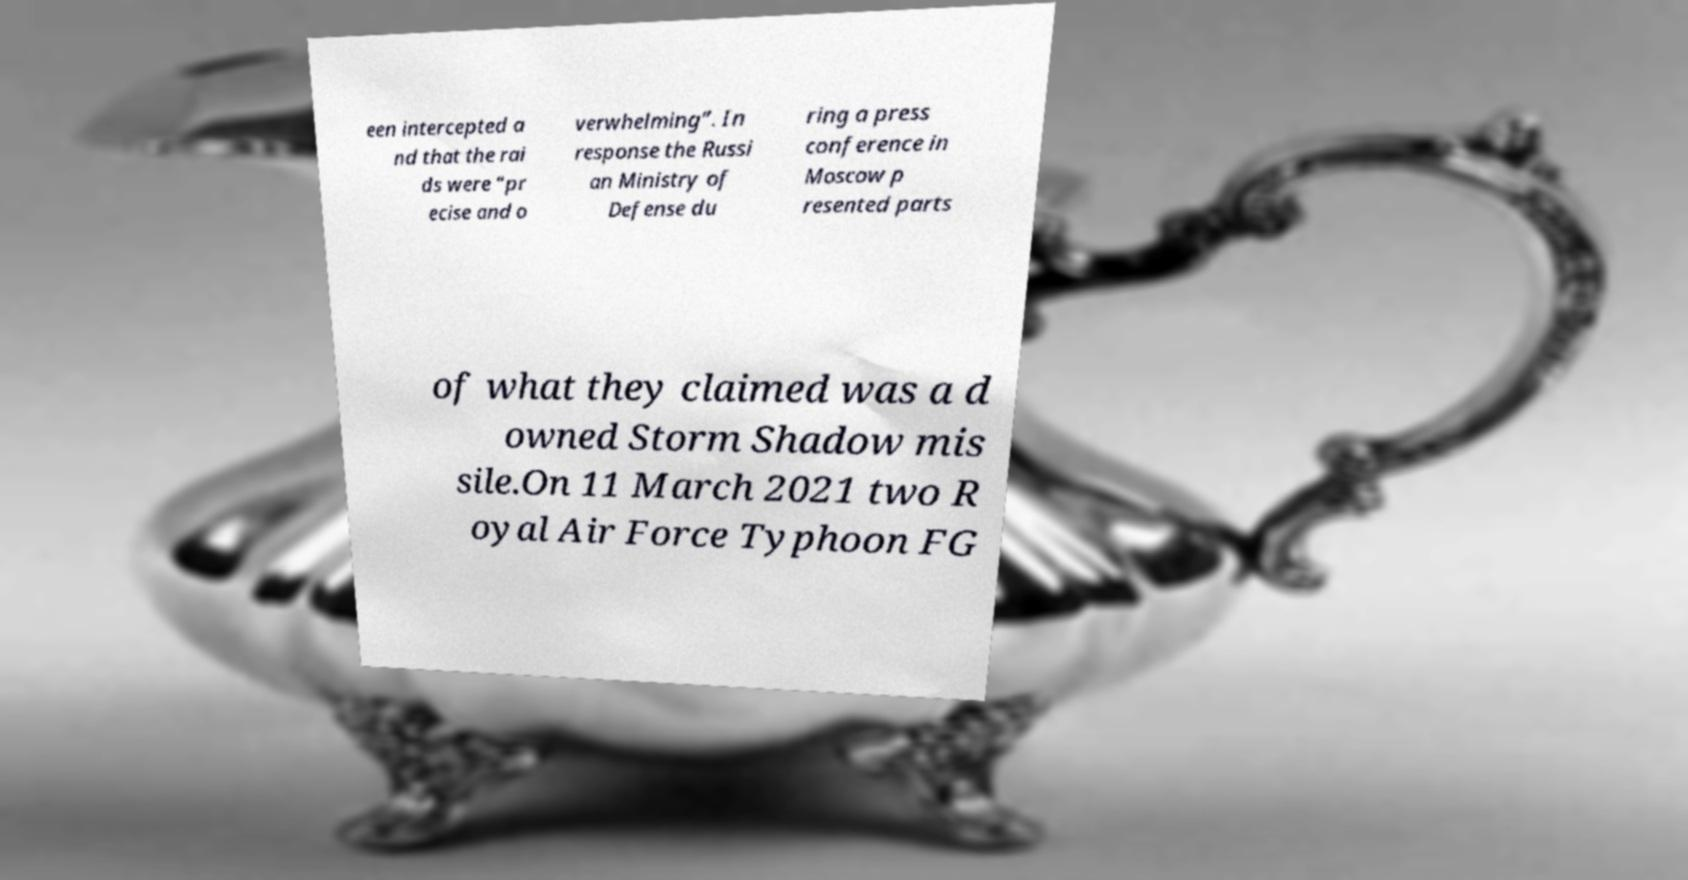There's text embedded in this image that I need extracted. Can you transcribe it verbatim? een intercepted a nd that the rai ds were “pr ecise and o verwhelming”. In response the Russi an Ministry of Defense du ring a press conference in Moscow p resented parts of what they claimed was a d owned Storm Shadow mis sile.On 11 March 2021 two R oyal Air Force Typhoon FG 